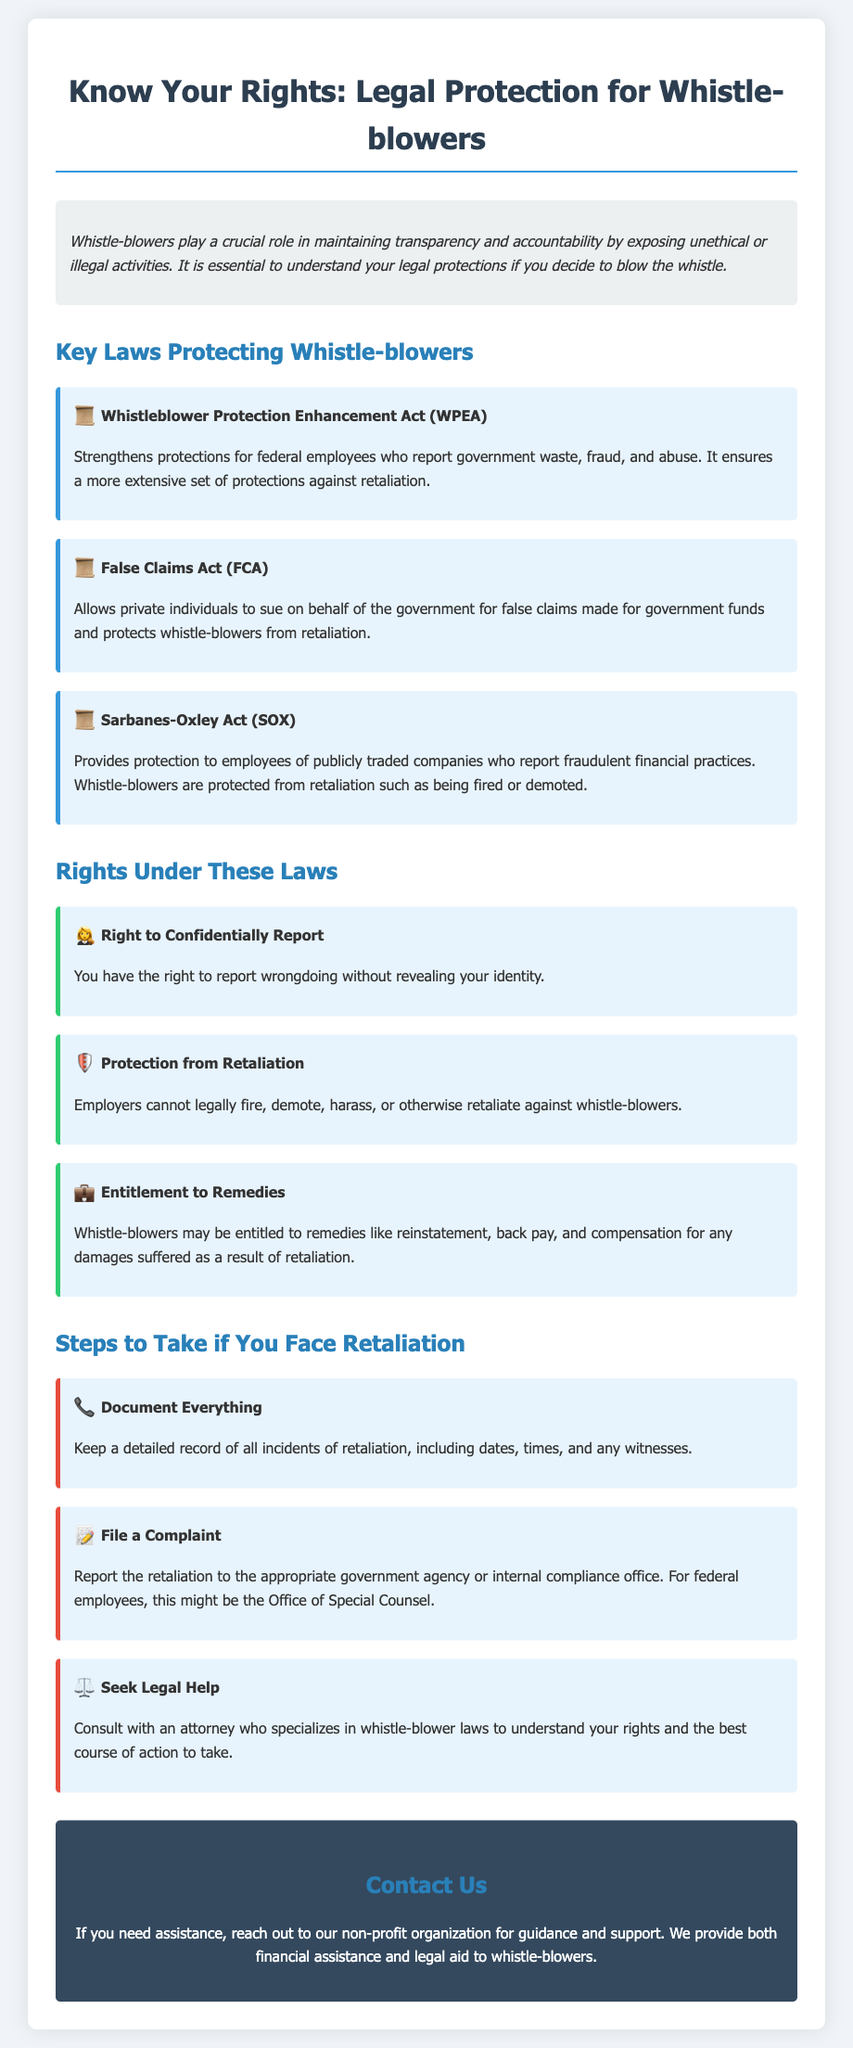What is the title of the flyer? The title of the flyer is the main heading that introduces its subject, which is "Know Your Rights: Legal Protection for Whistle-blowers."
Answer: Know Your Rights: Legal Protection for Whistle-blowers Which law strengthens protections for federal employees? This law is mentioned in the "Key Laws Protecting Whistle-blowers" section, specifically the Whistleblower Protection Enhancement Act (WPEA).
Answer: Whistleblower Protection Enhancement Act (WPEA) What is one right whistle-blowers have under the laws mentioned? The document specifies several rights under these laws, with one being "Right to Confidentially Report."
Answer: Right to Confidentially Report How many steps are listed for whistle-blowers facing retaliation? The document provides a numbered list of steps, which counts as three distinct steps to take in such cases.
Answer: 3 What should you do if you face retaliation? The flyer outlines specific actions to take, including documenting everything, filing a complaint, and seeking legal help.
Answer: Document Everything What color is used for the background of the contact section? The contact section has a distinct background color specified in the styling, which is a dark shade.
Answer: Dark blue Which act provides protection for employees reporting financial fraud? This act is highlighted in the document as providing protections specifically for fraudulent financial practices.
Answer: Sarbanes-Oxley Act (SOX) What kind of assistance does the non-profit organization offer? The organization is described as providing essential support for whistle-blowers, which includes financial assistance and legal aid.
Answer: Financial assistance and legal aid 